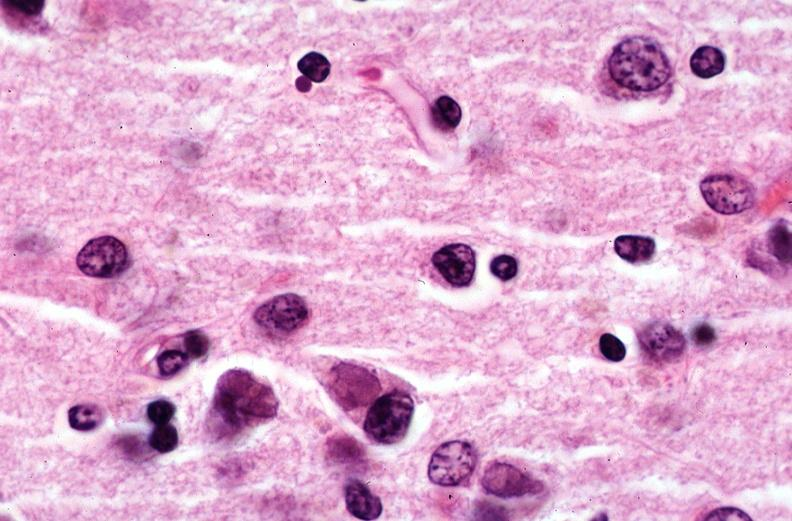s corpus luteum present?
Answer the question using a single word or phrase. No 